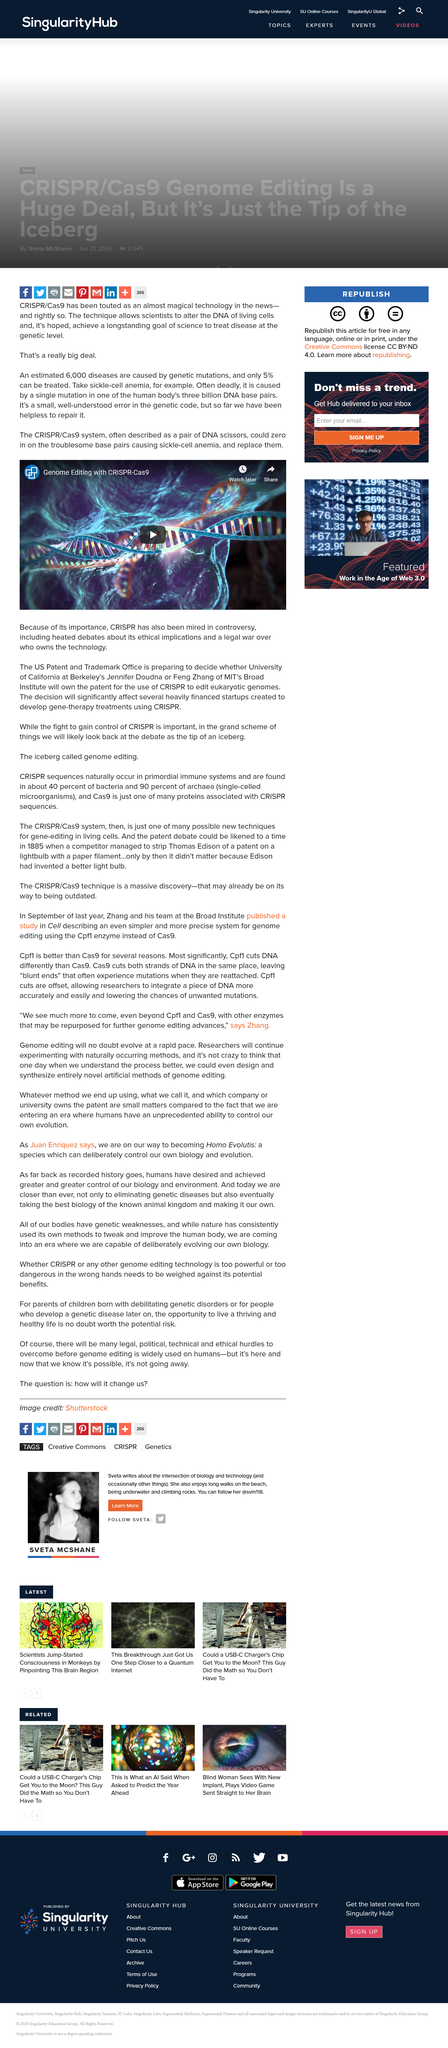Outline some significant characteristics in this image. The fight to gain control of CRISPR is indeed important. The CRISPR/Cas9 system is commonly referred to as a pair of DNA scissors due to its ability to cut and edit genes with high precision. The legal battle between Jennifer Doudna and Feng Zhang is due to the significance of CRISPR technology. Yes, it does exist. 